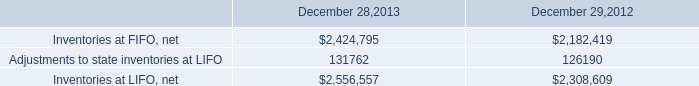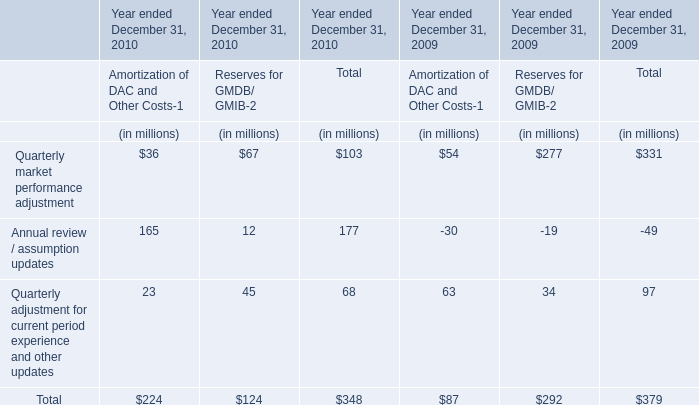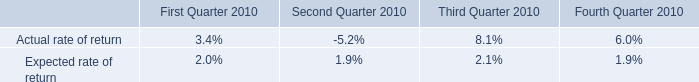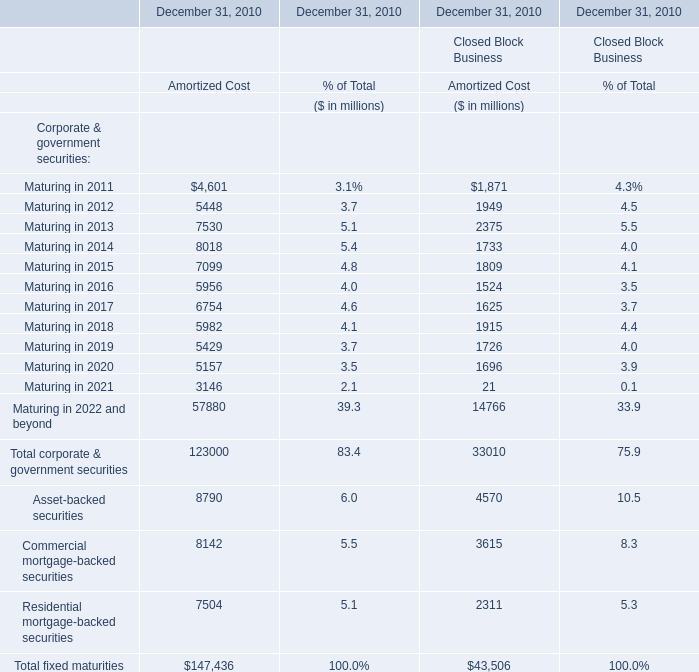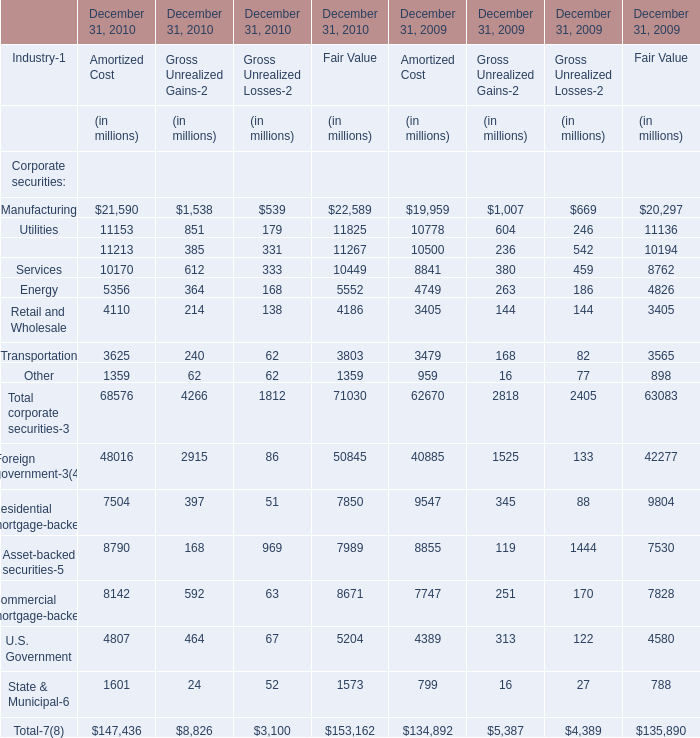What is the sum of the Finance in the years where Utilities for Fair Value greater than 11800? (in million) 
Computations: (((11213 + 385) + 331) + 11267)
Answer: 23196.0. 